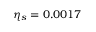Convert formula to latex. <formula><loc_0><loc_0><loc_500><loc_500>\eta _ { s } = 0 . 0 0 1 7</formula> 